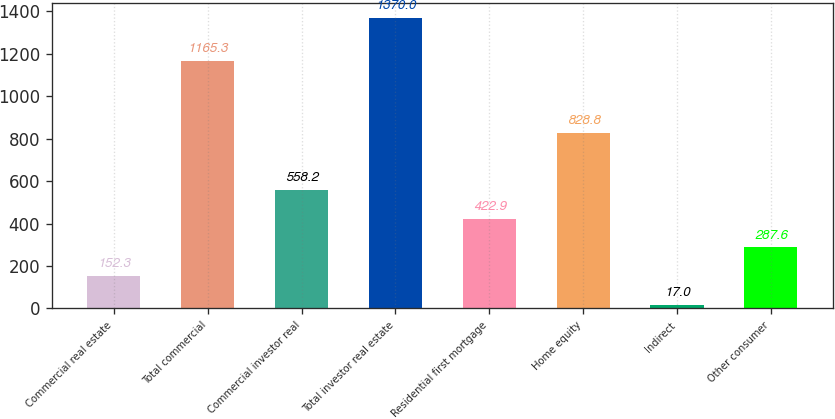<chart> <loc_0><loc_0><loc_500><loc_500><bar_chart><fcel>Commercial real estate<fcel>Total commercial<fcel>Commercial investor real<fcel>Total investor real estate<fcel>Residential first mortgage<fcel>Home equity<fcel>Indirect<fcel>Other consumer<nl><fcel>152.3<fcel>1165.3<fcel>558.2<fcel>1370<fcel>422.9<fcel>828.8<fcel>17<fcel>287.6<nl></chart> 